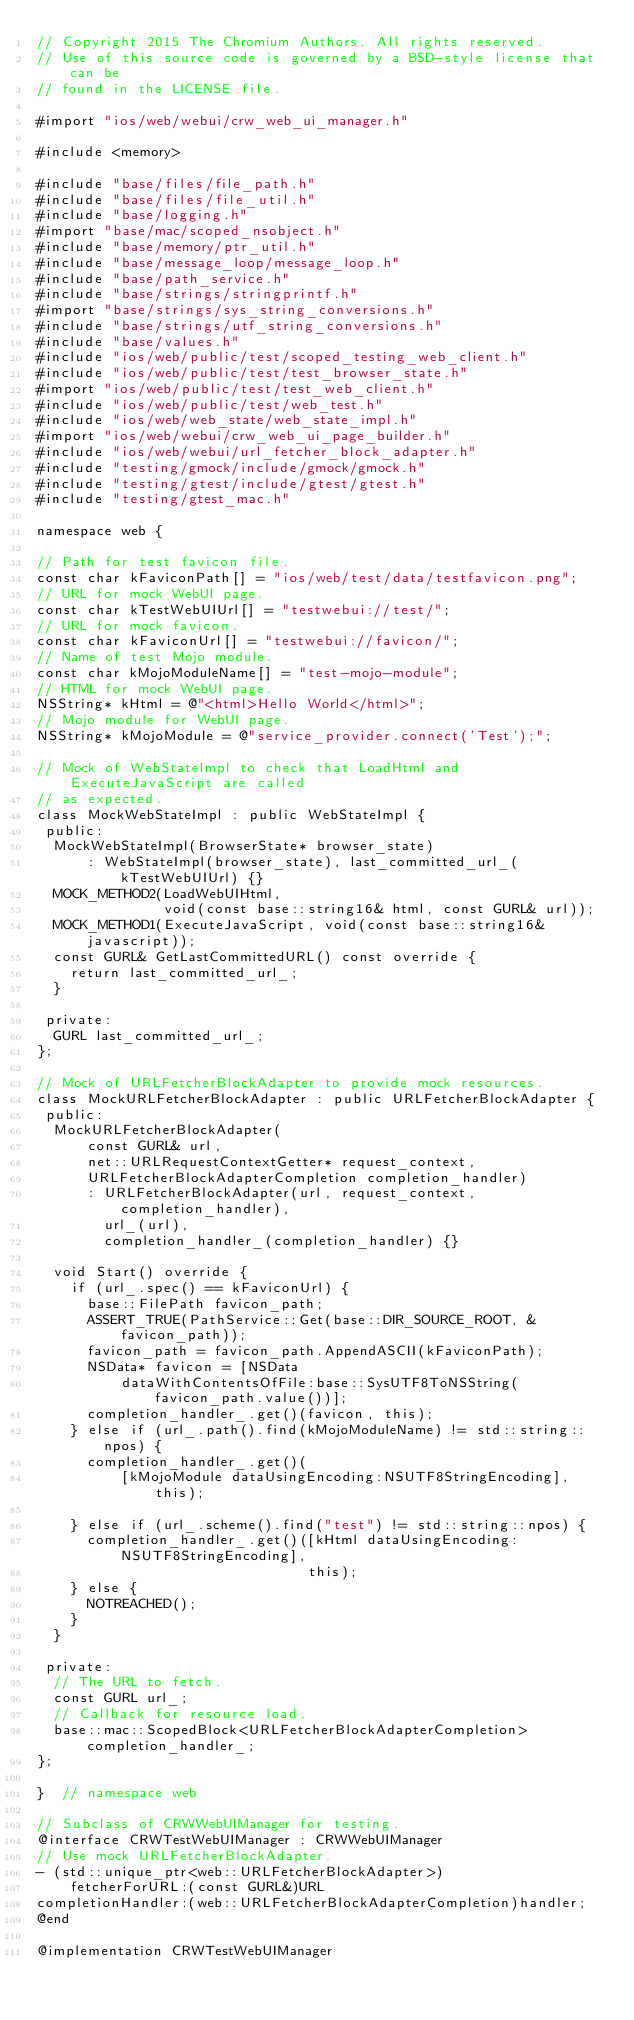<code> <loc_0><loc_0><loc_500><loc_500><_ObjectiveC_>// Copyright 2015 The Chromium Authors. All rights reserved.
// Use of this source code is governed by a BSD-style license that can be
// found in the LICENSE file.

#import "ios/web/webui/crw_web_ui_manager.h"

#include <memory>

#include "base/files/file_path.h"
#include "base/files/file_util.h"
#include "base/logging.h"
#import "base/mac/scoped_nsobject.h"
#include "base/memory/ptr_util.h"
#include "base/message_loop/message_loop.h"
#include "base/path_service.h"
#include "base/strings/stringprintf.h"
#import "base/strings/sys_string_conversions.h"
#include "base/strings/utf_string_conversions.h"
#include "base/values.h"
#include "ios/web/public/test/scoped_testing_web_client.h"
#include "ios/web/public/test/test_browser_state.h"
#import "ios/web/public/test/test_web_client.h"
#include "ios/web/public/test/web_test.h"
#include "ios/web/web_state/web_state_impl.h"
#import "ios/web/webui/crw_web_ui_page_builder.h"
#include "ios/web/webui/url_fetcher_block_adapter.h"
#include "testing/gmock/include/gmock/gmock.h"
#include "testing/gtest/include/gtest/gtest.h"
#include "testing/gtest_mac.h"

namespace web {

// Path for test favicon file.
const char kFaviconPath[] = "ios/web/test/data/testfavicon.png";
// URL for mock WebUI page.
const char kTestWebUIUrl[] = "testwebui://test/";
// URL for mock favicon.
const char kFaviconUrl[] = "testwebui://favicon/";
// Name of test Mojo module.
const char kMojoModuleName[] = "test-mojo-module";
// HTML for mock WebUI page.
NSString* kHtml = @"<html>Hello World</html>";
// Mojo module for WebUI page.
NSString* kMojoModule = @"service_provider.connect('Test');";

// Mock of WebStateImpl to check that LoadHtml and ExecuteJavaScript are called
// as expected.
class MockWebStateImpl : public WebStateImpl {
 public:
  MockWebStateImpl(BrowserState* browser_state)
      : WebStateImpl(browser_state), last_committed_url_(kTestWebUIUrl) {}
  MOCK_METHOD2(LoadWebUIHtml,
               void(const base::string16& html, const GURL& url));
  MOCK_METHOD1(ExecuteJavaScript, void(const base::string16& javascript));
  const GURL& GetLastCommittedURL() const override {
    return last_committed_url_;
  }

 private:
  GURL last_committed_url_;
};

// Mock of URLFetcherBlockAdapter to provide mock resources.
class MockURLFetcherBlockAdapter : public URLFetcherBlockAdapter {
 public:
  MockURLFetcherBlockAdapter(
      const GURL& url,
      net::URLRequestContextGetter* request_context,
      URLFetcherBlockAdapterCompletion completion_handler)
      : URLFetcherBlockAdapter(url, request_context, completion_handler),
        url_(url),
        completion_handler_(completion_handler) {}

  void Start() override {
    if (url_.spec() == kFaviconUrl) {
      base::FilePath favicon_path;
      ASSERT_TRUE(PathService::Get(base::DIR_SOURCE_ROOT, &favicon_path));
      favicon_path = favicon_path.AppendASCII(kFaviconPath);
      NSData* favicon = [NSData
          dataWithContentsOfFile:base::SysUTF8ToNSString(favicon_path.value())];
      completion_handler_.get()(favicon, this);
    } else if (url_.path().find(kMojoModuleName) != std::string::npos) {
      completion_handler_.get()(
          [kMojoModule dataUsingEncoding:NSUTF8StringEncoding], this);

    } else if (url_.scheme().find("test") != std::string::npos) {
      completion_handler_.get()([kHtml dataUsingEncoding:NSUTF8StringEncoding],
                                this);
    } else {
      NOTREACHED();
    }
  }

 private:
  // The URL to fetch.
  const GURL url_;
  // Callback for resource load.
  base::mac::ScopedBlock<URLFetcherBlockAdapterCompletion> completion_handler_;
};

}  // namespace web

// Subclass of CRWWebUIManager for testing.
@interface CRWTestWebUIManager : CRWWebUIManager
// Use mock URLFetcherBlockAdapter.
- (std::unique_ptr<web::URLFetcherBlockAdapter>)
    fetcherForURL:(const GURL&)URL
completionHandler:(web::URLFetcherBlockAdapterCompletion)handler;
@end

@implementation CRWTestWebUIManager</code> 